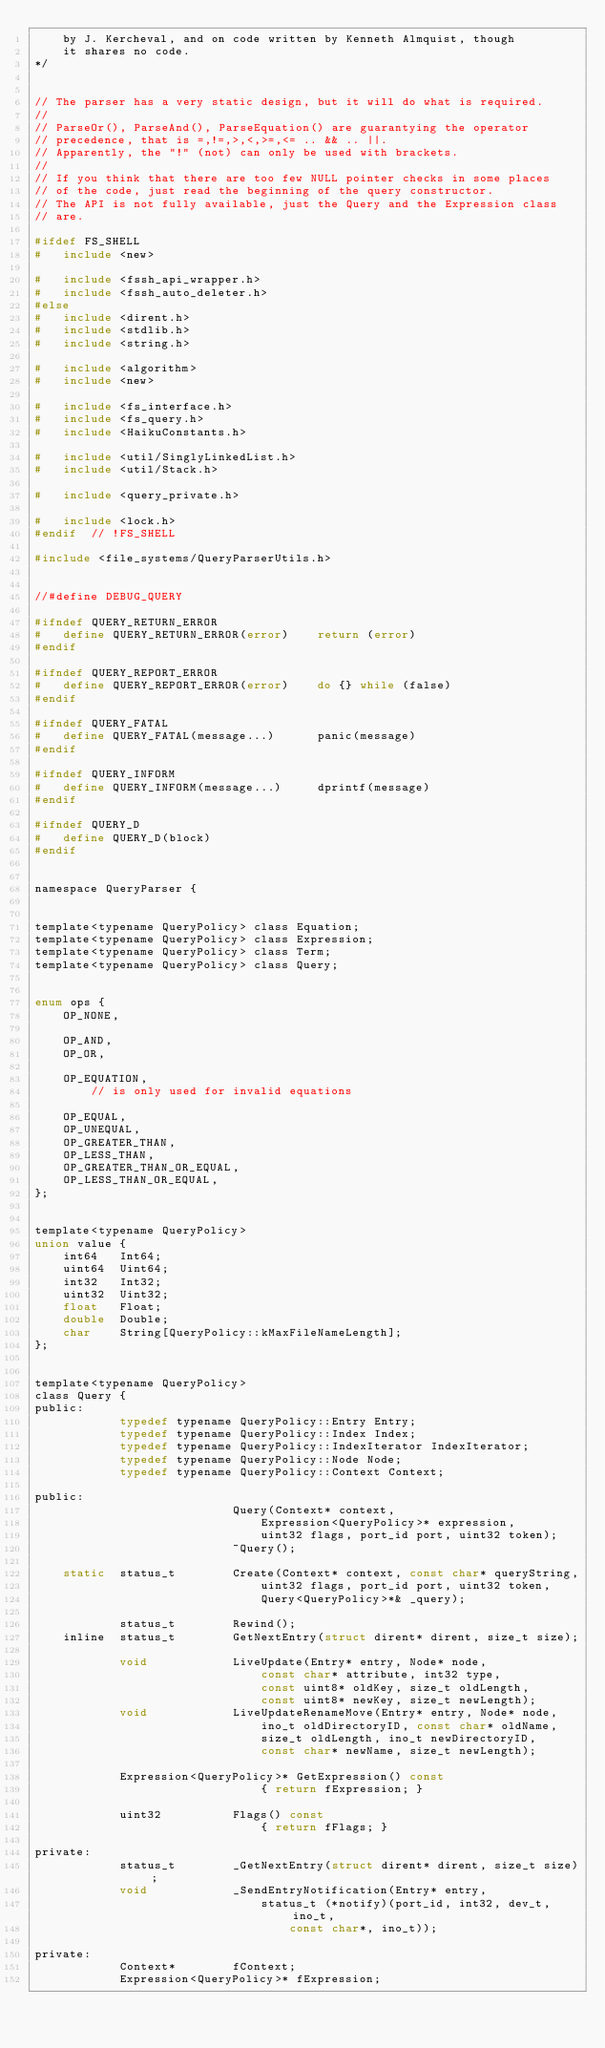Convert code to text. <code><loc_0><loc_0><loc_500><loc_500><_C_>	by J. Kercheval, and on code written by Kenneth Almquist, though
	it shares no code.
*/


// The parser has a very static design, but it will do what is required.
//
// ParseOr(), ParseAnd(), ParseEquation() are guarantying the operator
// precedence, that is =,!=,>,<,>=,<= .. && .. ||.
// Apparently, the "!" (not) can only be used with brackets.
//
// If you think that there are too few NULL pointer checks in some places
// of the code, just read the beginning of the query constructor.
// The API is not fully available, just the Query and the Expression class
// are.

#ifdef FS_SHELL
#	include <new>

#	include <fssh_api_wrapper.h>
#	include <fssh_auto_deleter.h>
#else
#	include <dirent.h>
#	include <stdlib.h>
#	include <string.h>

#	include <algorithm>
#	include <new>

#	include <fs_interface.h>
#	include <fs_query.h>
#	include <HaikuConstants.h>

#	include <util/SinglyLinkedList.h>
#	include <util/Stack.h>

#	include <query_private.h>

#	include <lock.h>
#endif	// !FS_SHELL

#include <file_systems/QueryParserUtils.h>


//#define DEBUG_QUERY

#ifndef QUERY_RETURN_ERROR
#	define QUERY_RETURN_ERROR(error)	return (error)
#endif

#ifndef QUERY_REPORT_ERROR
#	define QUERY_REPORT_ERROR(error)	do {} while (false)
#endif

#ifndef QUERY_FATAL
#	define QUERY_FATAL(message...)		panic(message)
#endif

#ifndef QUERY_INFORM
#	define QUERY_INFORM(message...)		dprintf(message)
#endif

#ifndef QUERY_D
#	define QUERY_D(block)
#endif


namespace QueryParser {


template<typename QueryPolicy> class Equation;
template<typename QueryPolicy> class Expression;
template<typename QueryPolicy> class Term;
template<typename QueryPolicy> class Query;


enum ops {
	OP_NONE,

	OP_AND,
	OP_OR,

	OP_EQUATION,
		// is only used for invalid equations

	OP_EQUAL,
	OP_UNEQUAL,
	OP_GREATER_THAN,
	OP_LESS_THAN,
	OP_GREATER_THAN_OR_EQUAL,
	OP_LESS_THAN_OR_EQUAL,
};


template<typename QueryPolicy>
union value {
	int64	Int64;
	uint64	Uint64;
	int32	Int32;
	uint32	Uint32;
	float	Float;
	double	Double;
	char	String[QueryPolicy::kMaxFileNameLength];
};


template<typename QueryPolicy>
class Query {
public:
			typedef typename QueryPolicy::Entry Entry;
			typedef typename QueryPolicy::Index Index;
			typedef typename QueryPolicy::IndexIterator IndexIterator;
			typedef typename QueryPolicy::Node Node;
			typedef typename QueryPolicy::Context Context;

public:
							Query(Context* context,
								Expression<QueryPolicy>* expression,
								uint32 flags, port_id port, uint32 token);
							~Query();

	static	status_t		Create(Context* context, const char* queryString,
								uint32 flags, port_id port, uint32 token,
								Query<QueryPolicy>*& _query);

			status_t		Rewind();
	inline	status_t		GetNextEntry(struct dirent* dirent, size_t size);

			void			LiveUpdate(Entry* entry, Node* node,
								const char* attribute, int32 type,
								const uint8* oldKey, size_t oldLength,
								const uint8* newKey, size_t newLength);
			void			LiveUpdateRenameMove(Entry* entry, Node* node,
								ino_t oldDirectoryID, const char* oldName,
								size_t oldLength, ino_t newDirectoryID,
								const char* newName, size_t newLength);

			Expression<QueryPolicy>* GetExpression() const
								{ return fExpression; }

			uint32			Flags() const
								{ return fFlags; }

private:
			status_t		_GetNextEntry(struct dirent* dirent, size_t size);
			void			_SendEntryNotification(Entry* entry,
								status_t (*notify)(port_id, int32, dev_t, ino_t,
									const char*, ino_t));

private:
			Context*		fContext;
			Expression<QueryPolicy>* fExpression;</code> 